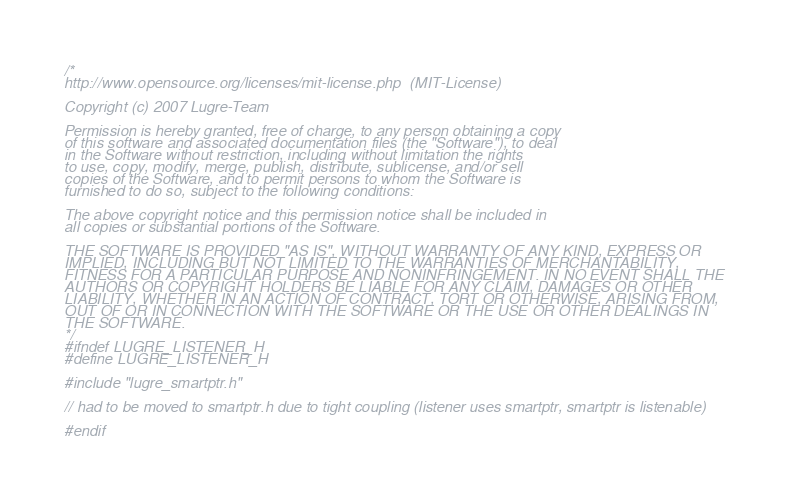<code> <loc_0><loc_0><loc_500><loc_500><_C_>/*
http://www.opensource.org/licenses/mit-license.php  (MIT-License)

Copyright (c) 2007 Lugre-Team

Permission is hereby granted, free of charge, to any person obtaining a copy
of this software and associated documentation files (the "Software"), to deal
in the Software without restriction, including without limitation the rights
to use, copy, modify, merge, publish, distribute, sublicense, and/or sell
copies of the Software, and to permit persons to whom the Software is
furnished to do so, subject to the following conditions:

The above copyright notice and this permission notice shall be included in
all copies or substantial portions of the Software.

THE SOFTWARE IS PROVIDED "AS IS", WITHOUT WARRANTY OF ANY KIND, EXPRESS OR
IMPLIED, INCLUDING BUT NOT LIMITED TO THE WARRANTIES OF MERCHANTABILITY,
FITNESS FOR A PARTICULAR PURPOSE AND NONINFRINGEMENT. IN NO EVENT SHALL THE
AUTHORS OR COPYRIGHT HOLDERS BE LIABLE FOR ANY CLAIM, DAMAGES OR OTHER
LIABILITY, WHETHER IN AN ACTION OF CONTRACT, TORT OR OTHERWISE, ARISING FROM,
OUT OF OR IN CONNECTION WITH THE SOFTWARE OR THE USE OR OTHER DEALINGS IN
THE SOFTWARE.
*/
#ifndef LUGRE_LISTENER_H
#define LUGRE_LISTENER_H

#include "lugre_smartptr.h"

// had to be moved to smartptr.h due to tight coupling (listener uses smartptr, smartptr is listenable)

#endif
</code> 